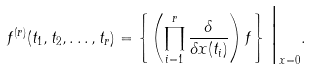Convert formula to latex. <formula><loc_0><loc_0><loc_500><loc_500>f ^ { ( r ) } ( t _ { 1 } , t _ { 2 } , \dots , t _ { r } ) = \left \{ \left ( \prod _ { i = 1 } ^ { r } \frac { \delta } { \delta x ( t _ { i } ) } \right ) f \right \} \Big | _ { x = 0 } .</formula> 